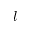Convert formula to latex. <formula><loc_0><loc_0><loc_500><loc_500>l</formula> 